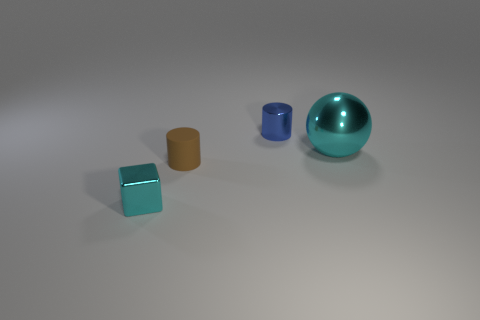Add 3 large cyan balls. How many objects exist? 7 Subtract all blocks. How many objects are left? 3 Subtract all big rubber cylinders. Subtract all small brown rubber things. How many objects are left? 3 Add 2 tiny blue objects. How many tiny blue objects are left? 3 Add 1 big purple objects. How many big purple objects exist? 1 Subtract 0 green cubes. How many objects are left? 4 